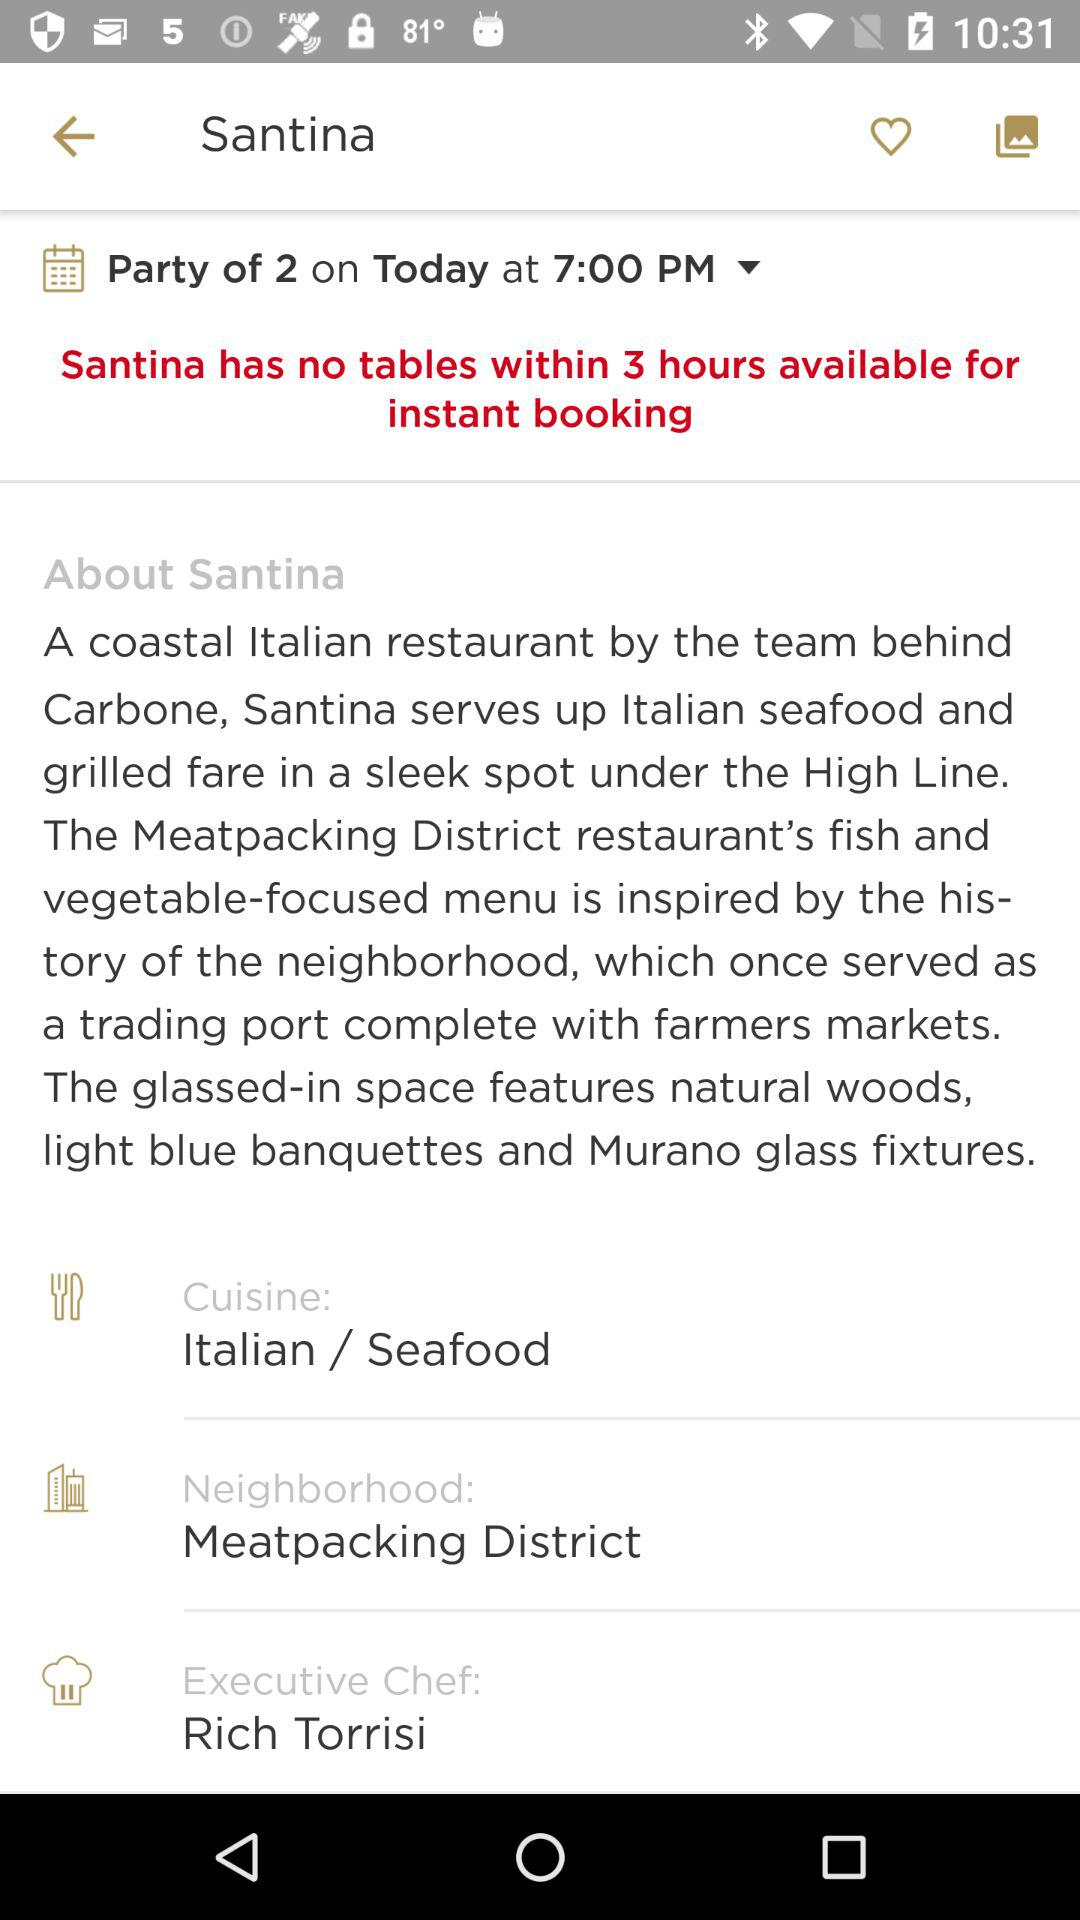For how many people is the party? The party is for 2 people. 